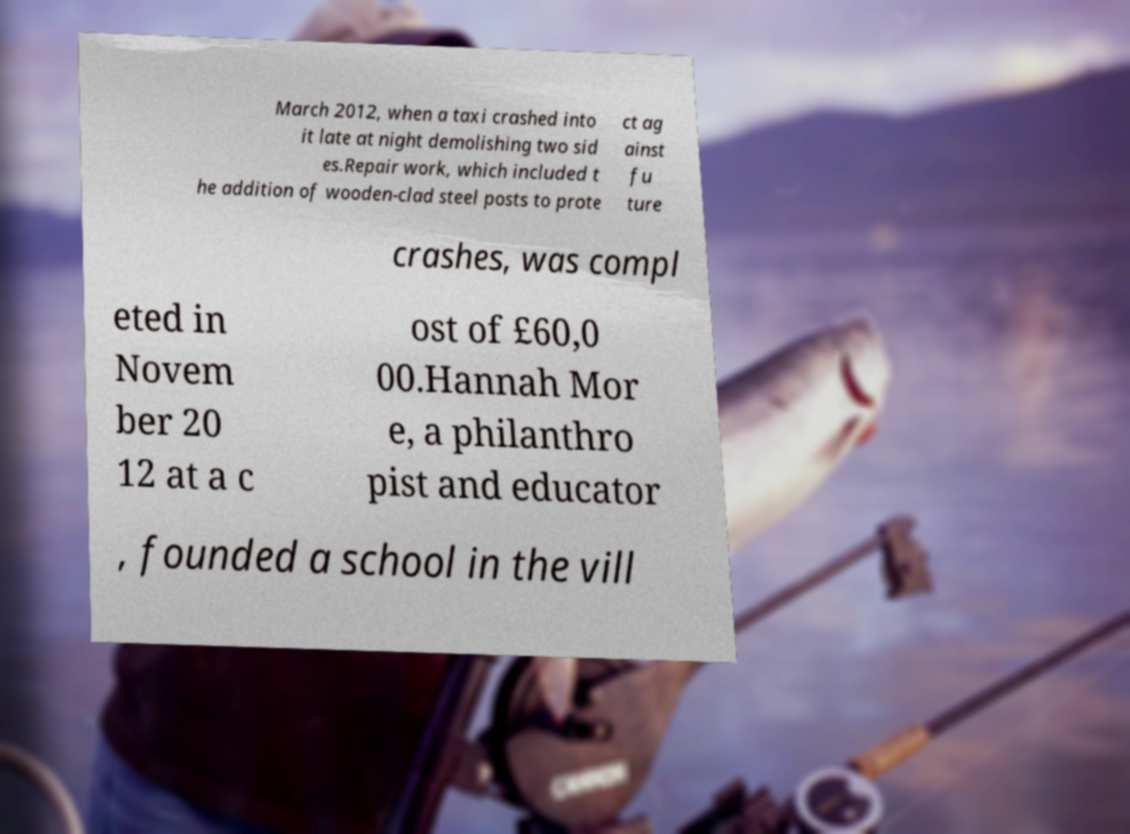Please identify and transcribe the text found in this image. March 2012, when a taxi crashed into it late at night demolishing two sid es.Repair work, which included t he addition of wooden-clad steel posts to prote ct ag ainst fu ture crashes, was compl eted in Novem ber 20 12 at a c ost of £60,0 00.Hannah Mor e, a philanthro pist and educator , founded a school in the vill 